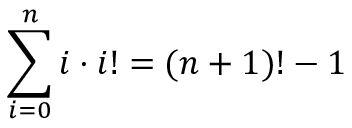<formula> <loc_0><loc_0><loc_500><loc_500>\sum _ { i = 0 } ^ { n } i \cdot i ! = ( n + 1 ) ! - 1</formula> 